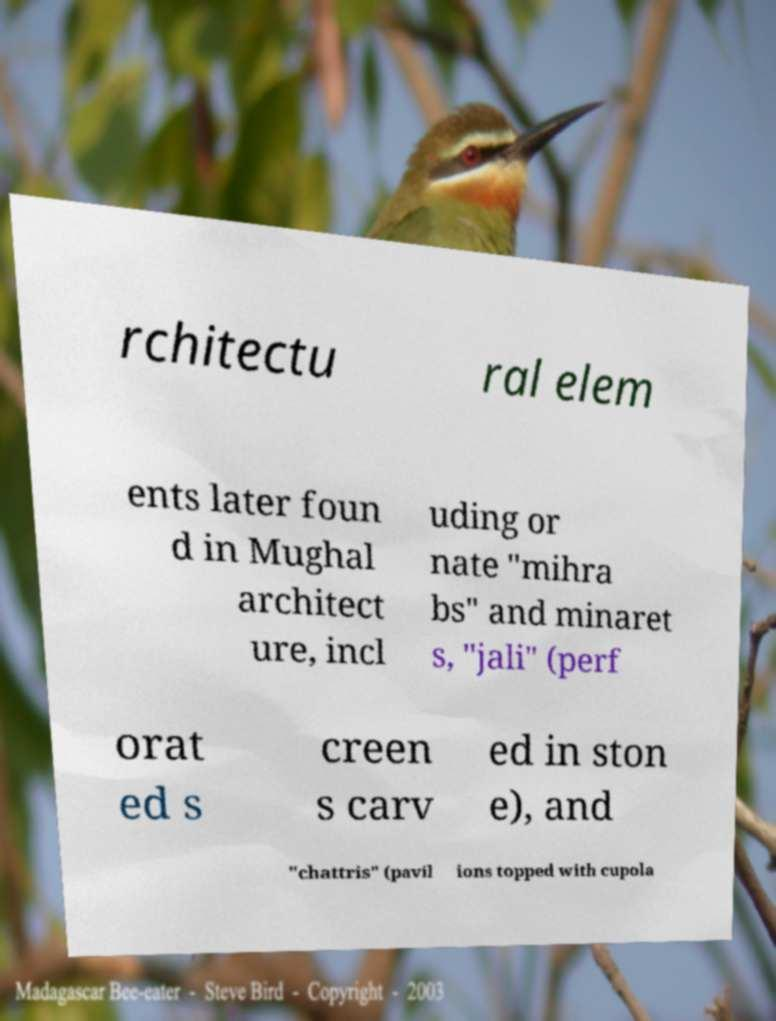What messages or text are displayed in this image? I need them in a readable, typed format. rchitectu ral elem ents later foun d in Mughal architect ure, incl uding or nate "mihra bs" and minaret s, "jali" (perf orat ed s creen s carv ed in ston e), and "chattris" (pavil ions topped with cupola 